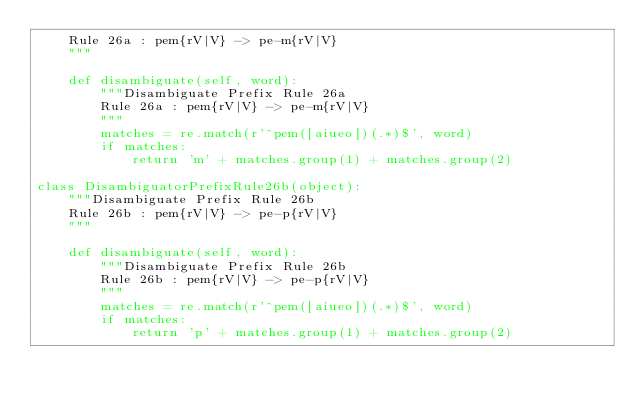<code> <loc_0><loc_0><loc_500><loc_500><_Python_>    Rule 26a : pem{rV|V} -> pe-m{rV|V}
    """
    
    def disambiguate(self, word):
        """Disambiguate Prefix Rule 26a
        Rule 26a : pem{rV|V} -> pe-m{rV|V}
        """
        matches = re.match(r'^pem([aiueo])(.*)$', word)
        if matches:
            return 'm' + matches.group(1) + matches.group(2)

class DisambiguatorPrefixRule26b(object):
    """Disambiguate Prefix Rule 26b
    Rule 26b : pem{rV|V} -> pe-p{rV|V}
    """
    
    def disambiguate(self, word):
        """Disambiguate Prefix Rule 26b
        Rule 26b : pem{rV|V} -> pe-p{rV|V}
        """
        matches = re.match(r'^pem([aiueo])(.*)$', word)
        if matches:
            return 'p' + matches.group(1) + matches.group(2)
</code> 